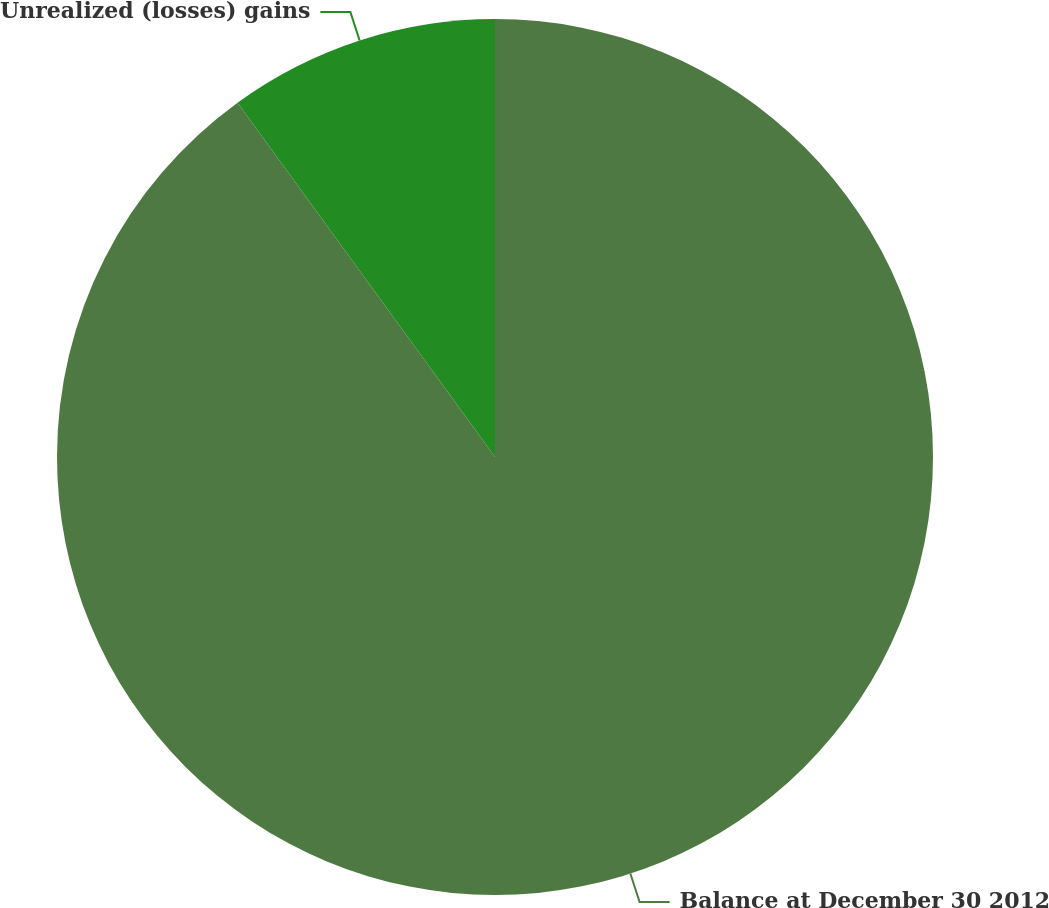Convert chart to OTSL. <chart><loc_0><loc_0><loc_500><loc_500><pie_chart><fcel>Balance at December 30 2012<fcel>Unrealized (losses) gains<nl><fcel>90.0%<fcel>10.0%<nl></chart> 